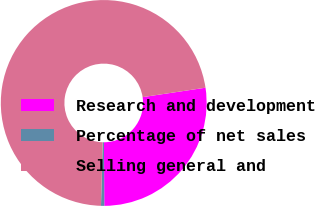<chart> <loc_0><loc_0><loc_500><loc_500><pie_chart><fcel>Research and development<fcel>Percentage of net sales<fcel>Selling general and<nl><fcel>27.28%<fcel>0.51%<fcel>72.21%<nl></chart> 